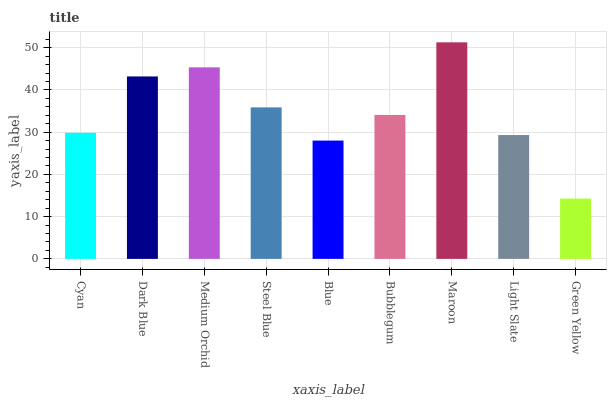Is Green Yellow the minimum?
Answer yes or no. Yes. Is Maroon the maximum?
Answer yes or no. Yes. Is Dark Blue the minimum?
Answer yes or no. No. Is Dark Blue the maximum?
Answer yes or no. No. Is Dark Blue greater than Cyan?
Answer yes or no. Yes. Is Cyan less than Dark Blue?
Answer yes or no. Yes. Is Cyan greater than Dark Blue?
Answer yes or no. No. Is Dark Blue less than Cyan?
Answer yes or no. No. Is Bubblegum the high median?
Answer yes or no. Yes. Is Bubblegum the low median?
Answer yes or no. Yes. Is Blue the high median?
Answer yes or no. No. Is Medium Orchid the low median?
Answer yes or no. No. 